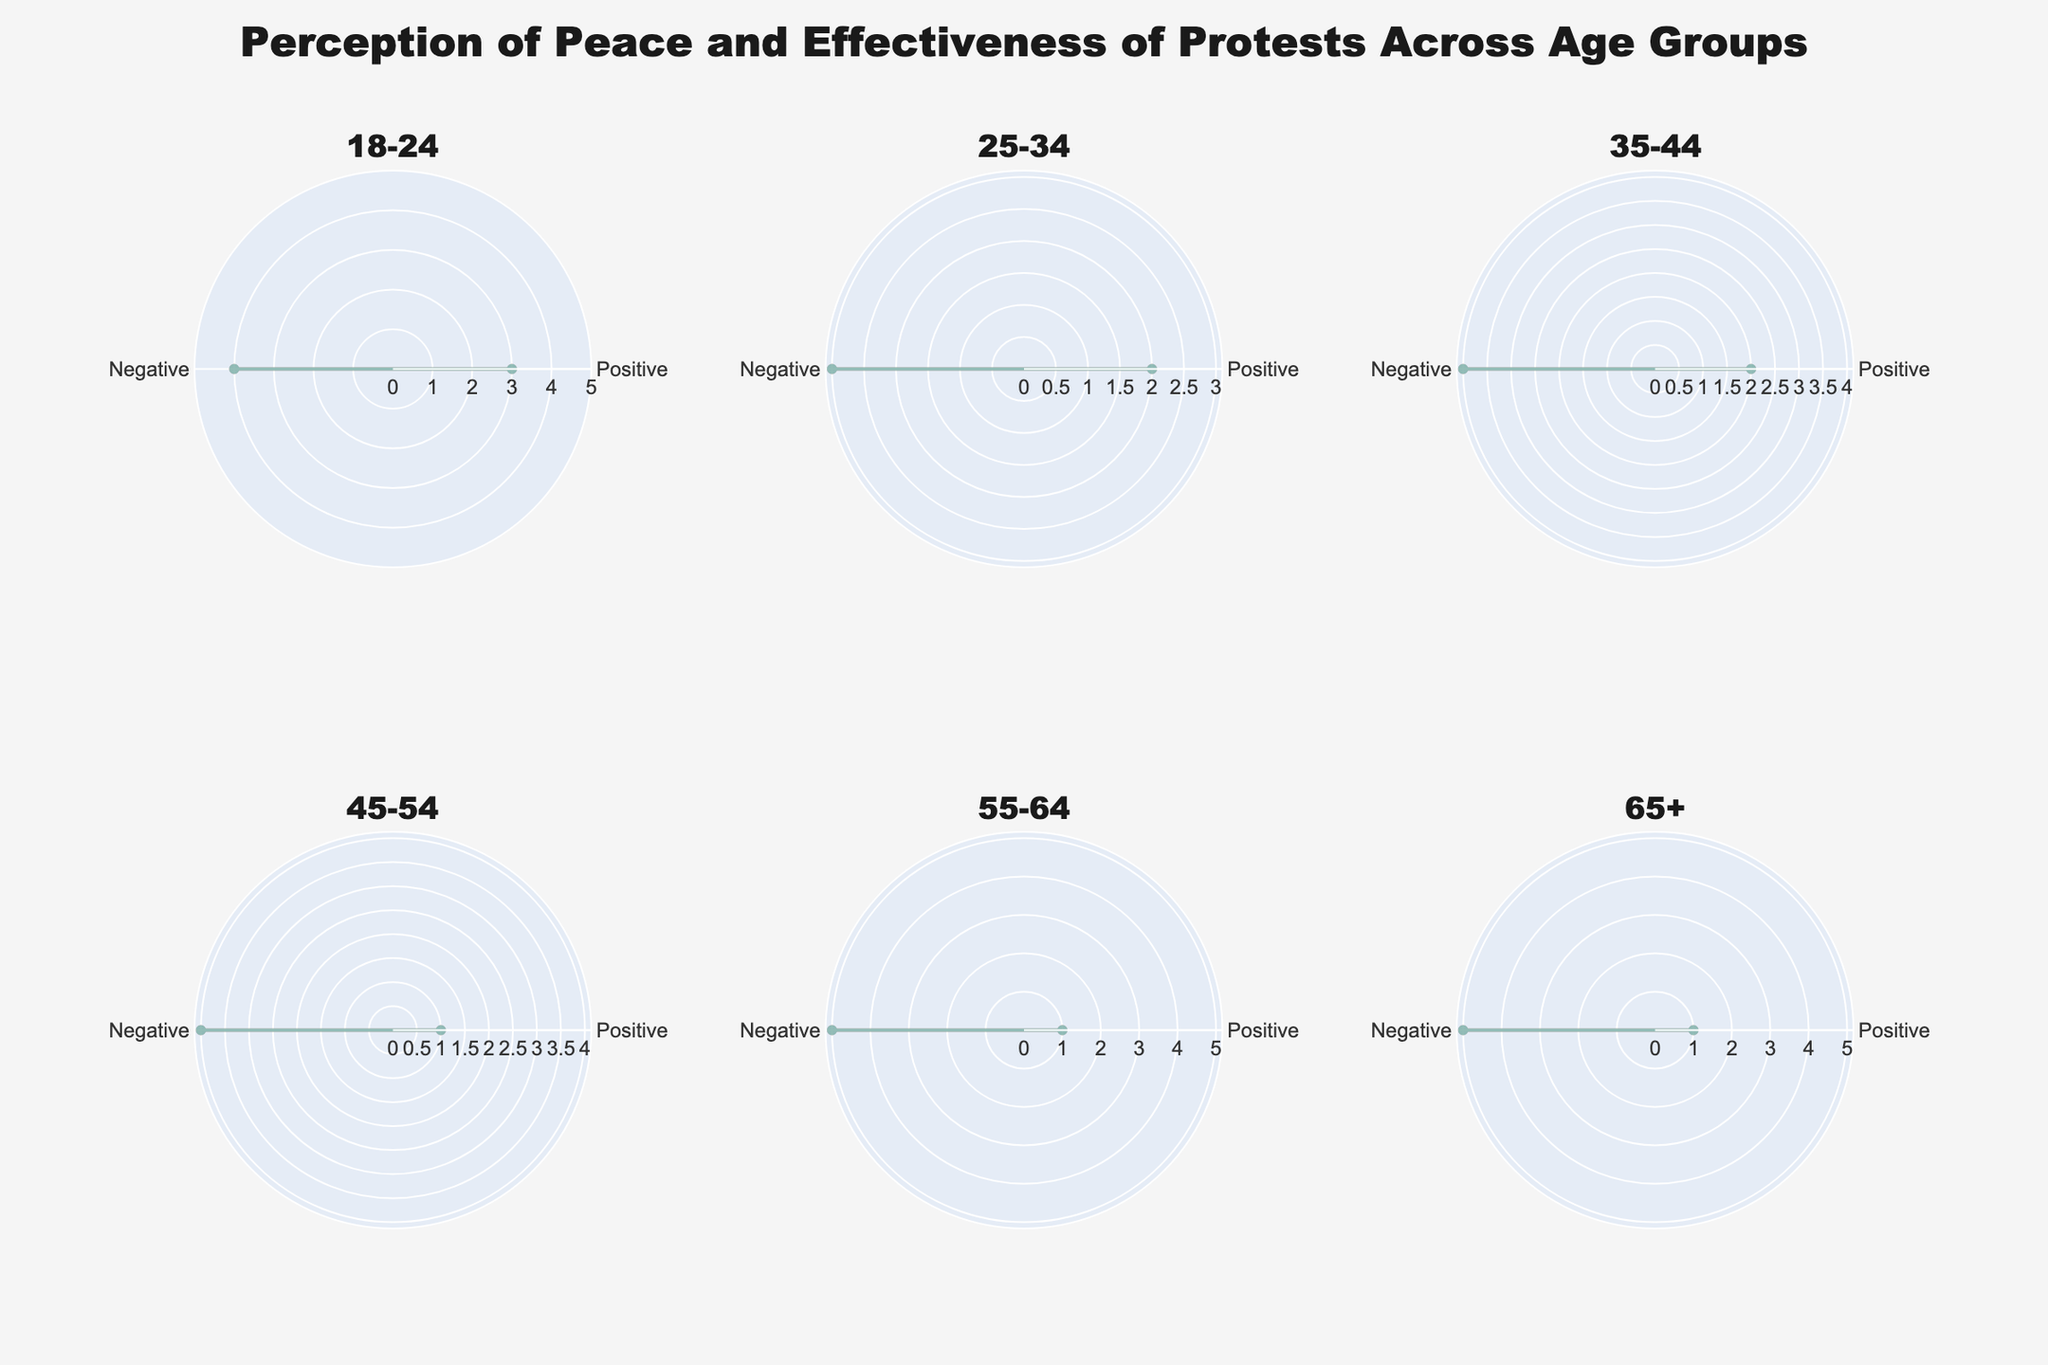What is the title of the figure? The title of the figure is usually displayed at the top or in another prominent position, often in a larger or bolder font to denote importance. Look for text that summarizes the entire plot.
Answer: Perception of Peace and Effectiveness of Protests Across Age Groups What are the radial axis ranges in the polar charts? Inspect the values and labels along the circular axes. The range is typically shown in a consistent interval around the charts.
Answer: 0 to 5 Which age group has the highest 'PeaceIsDifficult' perception? To determine the highest perception, compare the 'PeaceIsDifficult' Likert scale values for all age groups, and identify the group with the maximum value.
Answer: 55-64 For ages 18-24, how do 'ProtestsAreEffective' compare to 'ProtestsAreIneffective'? Look within the subplot for the 18-24 age group and compare the values indicated for 'ProtestsAreEffective' and 'ProtestsAreIneffective'. Note the relative sizes of the data points.
Answer: 'ProtestsAreEffective' is lower than 'ProtestsAreIneffective' What is the Likert scale value for 'WorldPeaceIsPossible' in the 45-54 age group? Locate the subplot for the 45-54 age group and identify the Likert scale value connected to 'WorldPeaceIsPossible'.
Answer: 1 Which age groups share the same perception values for 'WorldPeaceIsPossible'? Examine and compare the 'WorldPeaceIsPossible' Likert scale values across all age group subplots to find any identical values.
Answer: 45-54, 55-64, 65+ Compare the 'PeaceIsDifficult' values for the age groups 25-34 and 35-44. Which is higher? Look at the subplots for the 25-34 and 35-44 age groups and compare their 'PeaceIsDifficult' values to determine which is higher.
Answer: 35-44 Which category shows higher values in older age groups, 'PerceptionOfPeace' or 'EffectivenessOfProtests'? Analyze subplots for older age groups (55-64, 65+) and compare the Likert scale values for 'PerceptionOfPeace' and 'EffectivenessOfProtests' in each group.
Answer: EffectivenessOfProtests How does the 'ProtestsAreIneffective' perception vary across all age groups? By examining each subplot, collect the Likert scale values associated with 'ProtestsAreIneffective' for all age groups, then observe the trend.
Answer: Increases with age 